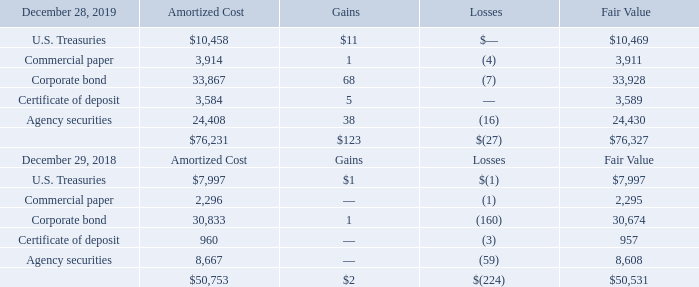Marketable Securities
Marketable securities consisted of the following (in thousands):
We classify our marketable securities as available-for-sale. All marketable securities represent the investment of funds available for current operations, notwithstanding their contractual maturities. Such marketable securities are recorded at fair value and unrealized gains and losses are recorded in Accumulated other comprehensive income (loss) until realized.
We typically invest in highly-rated securities with low probabilities of default. Our investment policy requires investments to be rated single A or better, limits the types of acceptable investments, concentration as to security holder and duration of the investment. The gross unrealized gains and losses in fiscal 2019 and 2018 were caused primarily by changes in interest rates.
The longer the duration of marketable securities, the more susceptible they are to changes in market interest rates and bond yields. As yields increase, those securities with a lower yield-at-cost show a mark-to-market unrealized loss. We anticipate recovering the full cost of the securities either as market conditions improve, or as the securities mature. Accordingly, we believe that the unrealized losses are not other-than-temporary.
When evaluating the investments for otherthan- temporary impairment, we review factors such as the length of time and extent to which fair value has been below the amortized cost basis, current market liquidity, interest rate risk, the financial condition of the issuer, and credit rating downgrades. As of December 28, 2019 and December 29, 2018, gross unrealized losses related to our marketable securities portfolio were not material.
How is marketable securities classified? We classify our marketable securities as available-for-sale. What is the increase/ (decrease) in Amortized Cost of U.S. Treasuries from Fiscal Year Ended December 28, 2019 to December 29, 2018?
Answer scale should be: thousand. 10,458-7,997
Answer: 2461. What is the increase/ (decrease) in Amortized Cost of Commercial paper from Fiscal Year Ended December 28, 2019 to December 29, 2018?
Answer scale should be: thousand. 3,914-2,296
Answer: 1618. What was the difference between the fair value of Commercial paper compared to U.S. Treasuries?
Answer scale should be: thousand. 10,469 - 3,911
Answer: 6558. What was the fair value of corporate bond?
Answer scale should be: thousand. 33,928. Where does the company typically invest? Highly-rated securities with low probabilities of default. 